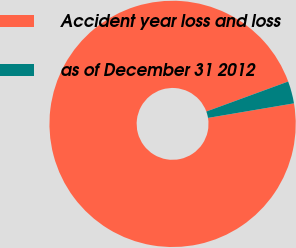Convert chart to OTSL. <chart><loc_0><loc_0><loc_500><loc_500><pie_chart><fcel>Accident year loss and loss<fcel>as of December 31 2012<nl><fcel>97.08%<fcel>2.92%<nl></chart> 